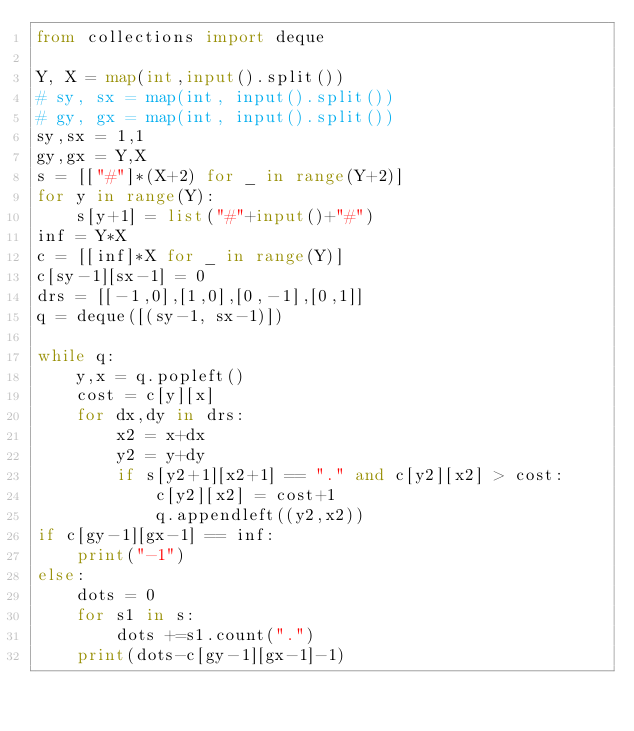<code> <loc_0><loc_0><loc_500><loc_500><_Python_>from collections import deque

Y, X = map(int,input().split())
# sy, sx = map(int, input().split())
# gy, gx = map(int, input().split())
sy,sx = 1,1
gy,gx = Y,X
s = [["#"]*(X+2) for _ in range(Y+2)]
for y in range(Y):
    s[y+1] = list("#"+input()+"#")
inf = Y*X
c = [[inf]*X for _ in range(Y)]
c[sy-1][sx-1] = 0
drs = [[-1,0],[1,0],[0,-1],[0,1]]
q = deque([(sy-1, sx-1)])

while q:
    y,x = q.popleft()
    cost = c[y][x]
    for dx,dy in drs:
        x2 = x+dx
        y2 = y+dy
        if s[y2+1][x2+1] == "." and c[y2][x2] > cost:
            c[y2][x2] = cost+1
            q.appendleft((y2,x2))
if c[gy-1][gx-1] == inf:
    print("-1")
else:
    dots = 0
    for s1 in s:
        dots +=s1.count(".")
    print(dots-c[gy-1][gx-1]-1)</code> 